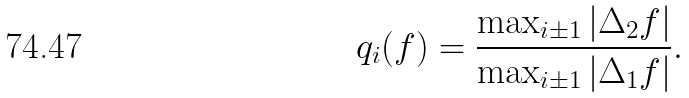Convert formula to latex. <formula><loc_0><loc_0><loc_500><loc_500>q _ { i } ( f ) = \frac { \max _ { i \pm 1 } | \Delta _ { 2 } f | } { \max _ { i \pm 1 } | \Delta _ { 1 } f | } .</formula> 